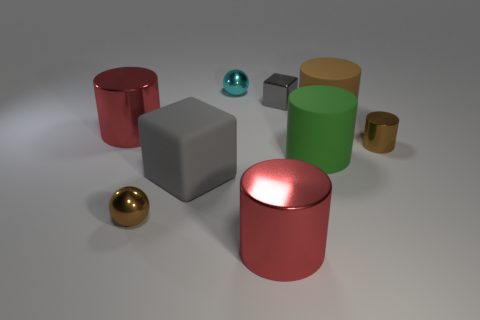Does the gray shiny object have the same shape as the large gray object?
Provide a succinct answer. Yes. What is the size of the metallic cylinder that is both left of the green cylinder and behind the large gray thing?
Give a very brief answer. Large. There is another thing that is the same shape as the small gray thing; what is its material?
Give a very brief answer. Rubber. What is the large green thing that is behind the brown shiny object in front of the green rubber cylinder made of?
Your response must be concise. Rubber. There is a small cyan metallic thing; is its shape the same as the brown object on the left side of the brown rubber cylinder?
Provide a short and direct response. Yes. How many matte objects are either tiny gray cubes or tiny objects?
Make the answer very short. 0. What color is the metal thing that is behind the small block to the right of the big red object in front of the brown sphere?
Offer a terse response. Cyan. How many other objects are the same material as the cyan thing?
Make the answer very short. 5. Do the small brown metallic object left of the tiny cyan metal sphere and the tiny cyan object have the same shape?
Your answer should be compact. Yes. How many tiny objects are either spheres or gray things?
Ensure brevity in your answer.  3. 